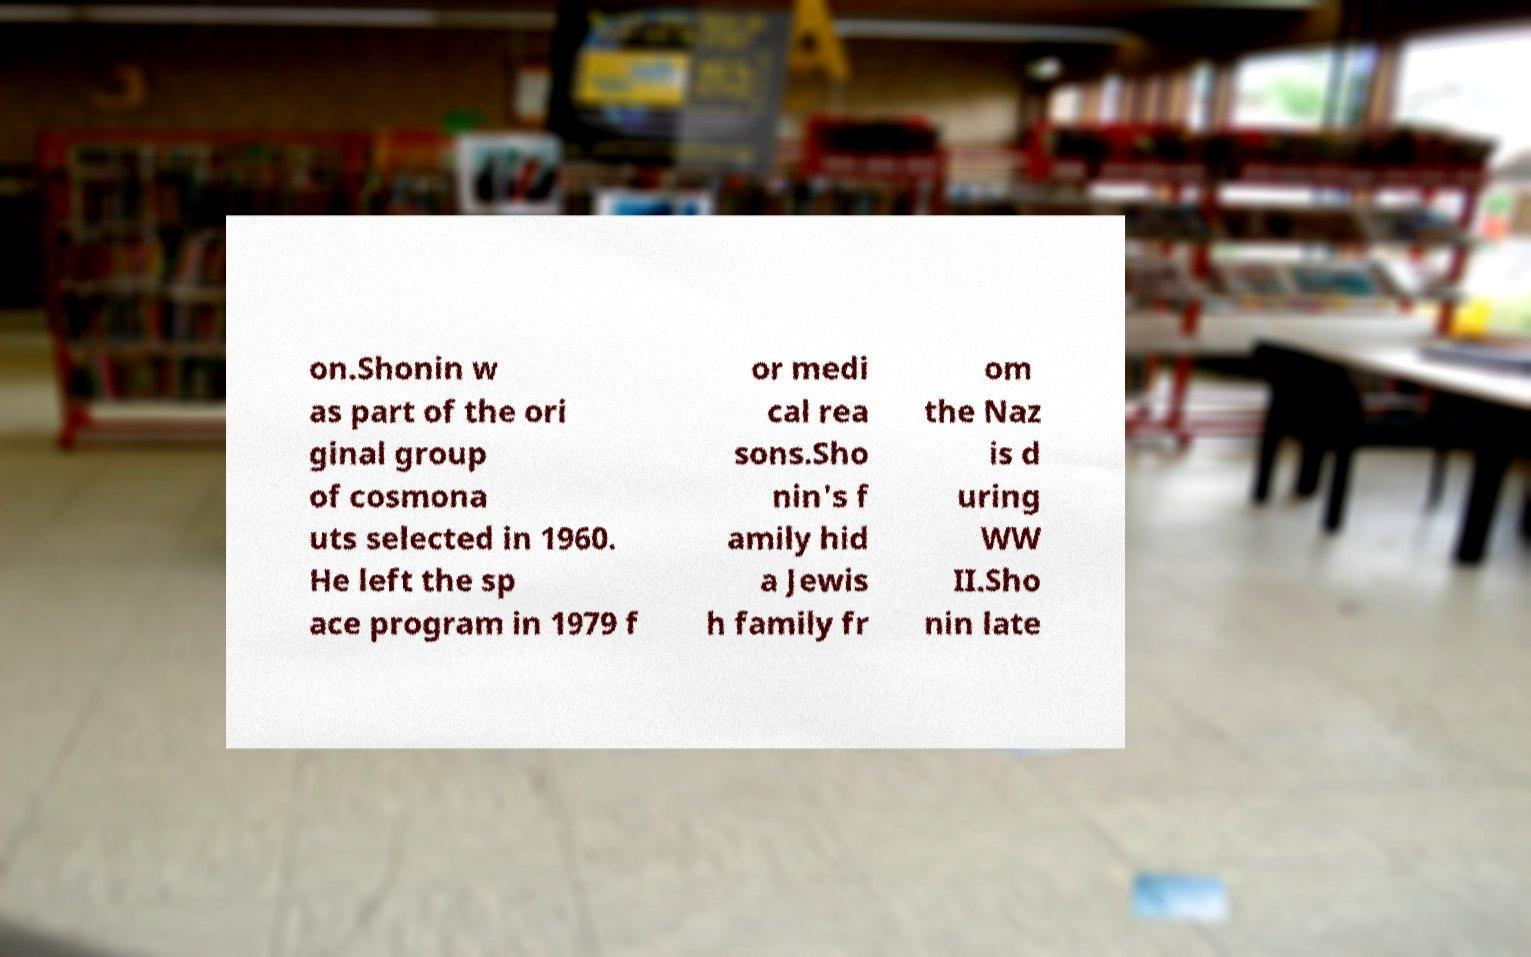Could you assist in decoding the text presented in this image and type it out clearly? on.Shonin w as part of the ori ginal group of cosmona uts selected in 1960. He left the sp ace program in 1979 f or medi cal rea sons.Sho nin's f amily hid a Jewis h family fr om the Naz is d uring WW II.Sho nin late 